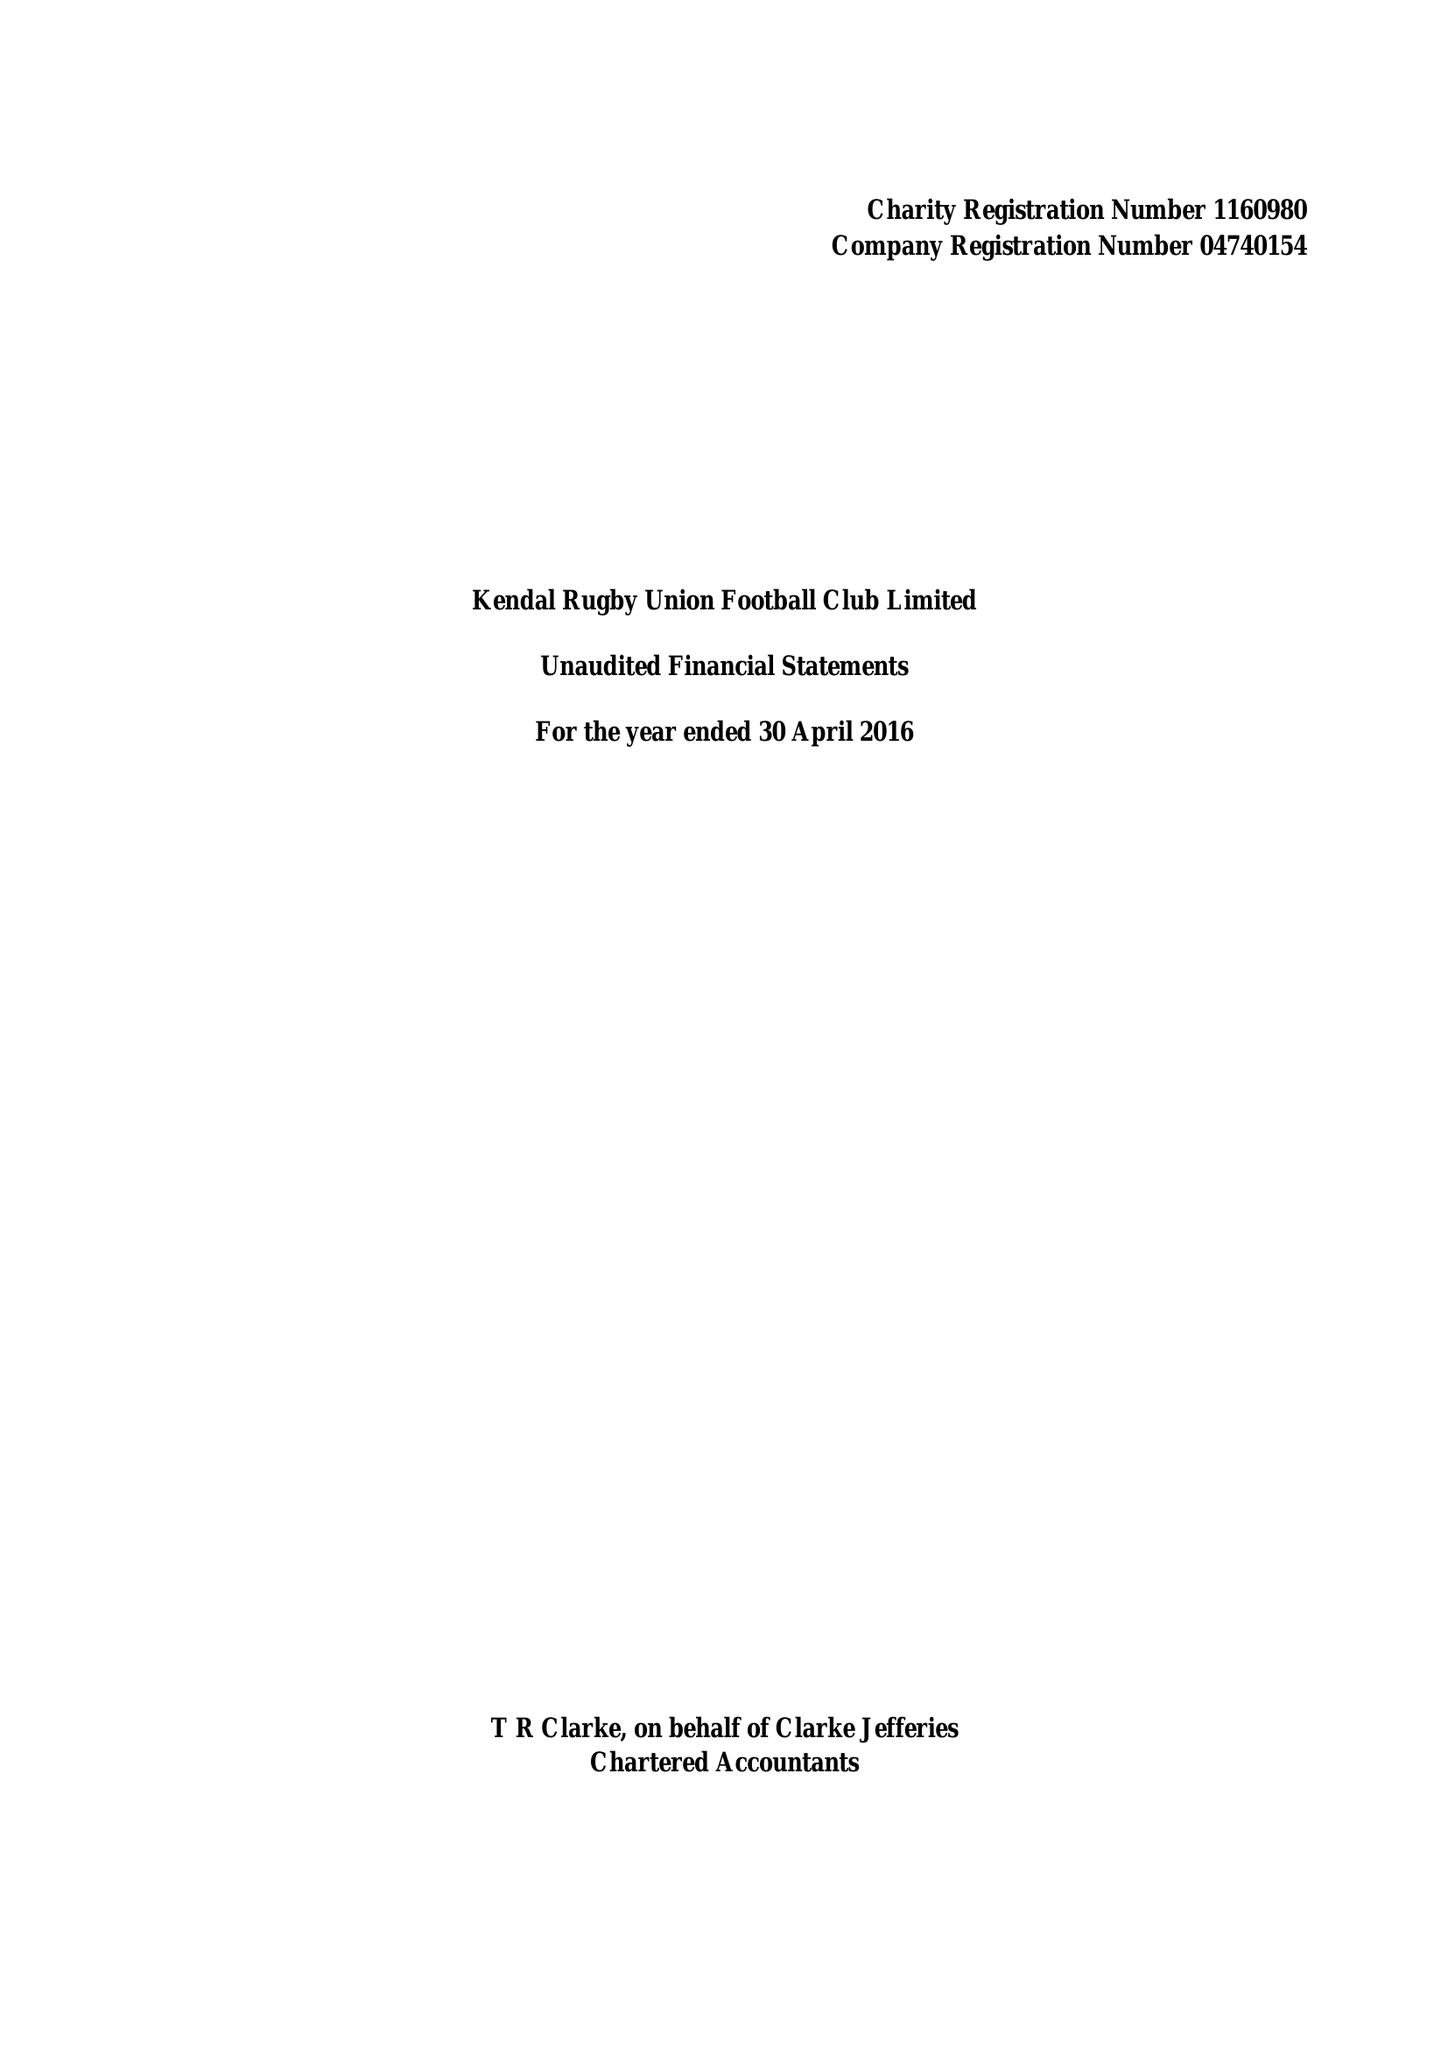What is the value for the address__post_town?
Answer the question using a single word or phrase. KENDAL 